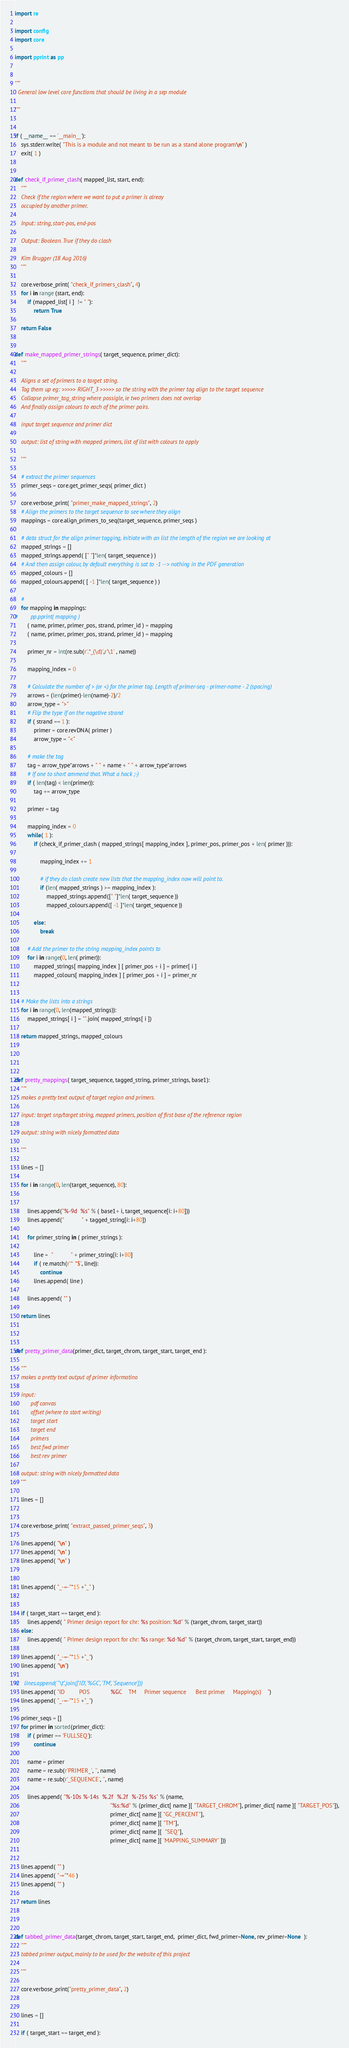<code> <loc_0><loc_0><loc_500><loc_500><_Python_>

import re

import config
import core

import pprint as pp


"""
  General low level core functions that should be living in a sep module

"""


if ( __name__ == '__main__'):
    sys.stderr.write( "This is a module and not meant to be run as a stand alone program\n" )
    exit( 1 )


def check_if_primer_clash( mapped_list, start, end):
    """
    Check if the region where we want to put a primer is alreay 
    occupied by another primer.

    Input: string, start-pos, end-pos
    
    Output: Boolean. True if they do clash
    
    Kim Brugger (18 Aug 2016)
    """
    
    core.verbose_print( "check_if_primers_clash", 4)
    for i in range (start, end):
        if (mapped_list[ i ]  != " "):
            return True 

    return False


def make_mapped_primer_strings( target_sequence, primer_dict):
    """

    Aligns a set of primers to a target string. 
    Tag them up eg: >>>>> RIGHT_3 >>>>> so the string with the primer tag align to the target sequence
    Collapse primer_tag_string where possigle, ie two primers does not overlap
    And finally assign colours to each of the primer pairs.
    
    input target sequence and primer dict
    
    output: list of string with mapped primers, list of list with colours to apply
    
    """

    # extract the primer sequences
    primer_seqs = core.get_primer_seqs( primer_dict )
    
    core.verbose_print( "primer_make_mapped_strings", 2)
    # Align the primers to the target sequence to see where they align
    mappings = core.align_primers_to_seq(target_sequence, primer_seqs )
    
    # data struct for the align primer tagging, initiate with an list the length of the region we are looking at
    mapped_strings = []
    mapped_strings.append( [" "]*len( target_sequence ) )
    # And then assign colour, by default everything is sat to -1 --> nothing in the PDF generation
    mapped_colours = []
    mapped_colours.append( [ -1 ]*len( target_sequence ) )

    #
    for mapping in mappings:
#        pp.pprint( mapping )
        ( name, primer, primer_pos, strand, primer_id ) = mapping
        ( name, primer, primer_pos, strand, primer_id ) = mapping

        primer_nr = int(re.sub(r'.*_(\d)',r'\1' , name))

        mapping_index = 0

        # Calculate the number of > (or <) for the primer tag. Length of primer-seq - primer-name - 2 (spacing)
        arrows = (len(primer)-len(name)-2)/2
        arrow_type = ">"
        # Flip the type if on the nagative strand
        if ( strand == 1 ):
            primer = core.revDNA( primer )
            arrow_type = "<"

        # make the tag
        tag = arrow_type*arrows + " " + name + " " + arrow_type*arrows
        # If one to short ammend that. What a hack ;-)
        if ( len(tag) < len(primer)):
            tag += arrow_type
            
        primer = tag 

        mapping_index = 0
        while( 1 ):
            if (check_if_primer_clash ( mapped_strings[ mapping_index ], primer_pos, primer_pos + len( primer ))):

                mapping_index += 1
                
                # if they do clash create new lists that the mapping_index now will point to.
                if (len( mapped_strings ) >= mapping_index ):
                    mapped_strings.append([" "]*len( target_sequence ))
                    mapped_colours.append([ -1 ]*len( target_sequence ))

            else:
                break

        # Add the primer to the string mapping_index points to
        for i in range(0, len( primer)):
            mapped_strings[ mapping_index ] [ primer_pos + i ] = primer[ i ]
            mapped_colours[ mapping_index ] [ primer_pos + i ] = primer_nr


    # Make the lists into a strings
    for i in range(0, len(mapped_strings)):
        mapped_strings[ i ] = "".join( mapped_strings[ i ])

    return mapped_strings, mapped_colours




def pretty_mappings( target_sequence, tagged_string, primer_strings, base1):
    """
    makes a pretty text output of target region and primers.
    
    input: target snp/target string, mapped primers, position of first base of the reference region
    
    output: string with nicely formatted data
    
    """

    lines = []
    
    for i in range(0, len(target_sequence), 80):


        lines.append("%-9d  %s" % ( base1+ i, target_sequence[i: i+80]))
        lines.append("           " + tagged_string[i: i+80])

        for primer_string in ( primer_strings ):

            line =  "           " + primer_string[i: i+80]
            if ( re.match(r'^ *$', line)):
                continue
            lines.append( line )

        lines.append( "" )

    return lines



def pretty_primer_data(primer_dict, target_chrom, target_start, target_end ):

    """
    makes a pretty text output of primer informatino

    input: 
          pdf canvas
          offset (where to start writing) 
          target start
          target end
          primers
          best fwd primer
          best rev primer

    output: string with nicely formatted data
    """

    lines = []


    core.verbose_print( "extract_passed_primer_seqs", 3)

    lines.append( "\n" )
    lines.append( "\n" )
    lines.append( "\n" )


    lines.append( "_-=-"*15 +"_" )


    if ( target_start == target_end ):
        lines.append( " Primer design report for chr: %s position: %d" % (target_chrom, target_start))
    else:
        lines.append( " Primer design report for chr: %s range: %d-%d" % (target_chrom, target_start, target_end))

    lines.append( "_-=-"*15 +"_")
    lines.append( "\n")

#    lines.append( "\t".join(['ID', '%GC', 'TM', 'Sequence']))
    lines.append( "ID         POS             %GC    TM     Primer sequence      Best primer     Mapping(s)    ")
    lines.append( "_-=-"*15 +"_")

    primer_seqs = []
    for primer in sorted(primer_dict):
        if ( primer == 'FULLSEQ'):
            continue

        name = primer
        name = re.sub(r'PRIMER_', '', name)
        name = re.sub(r'_SEQUENCE', '', name)

        lines.append( "%-10s %-14s  %.2f  %.2f  %-25s %s" % (name,
                                                            "%s:%d" % (primer_dict[ name ][ "TARGET_CHROM"], primer_dict[ name ][ "TARGET_POS"]),
                                                            primer_dict[ name ][ "GC_PERCENT"], 
                                                            primer_dict[ name ][ "TM"],
                                                            primer_dict[ name ][  "SEQ"], 
                                                            primer_dict[ name ][ 'MAPPING_SUMMARY' ]))


    lines.append( "" )
    lines.append( "-="*46 )
    lines.append( "" )

    return lines



def tabbed_primer_data(target_chrom, target_start, target_end,  primer_dict, fwd_primer=None, rev_primer=None  ):
    """
    tabbed primer output, mainly to be used for the website of this project

    """

    core.verbose_print("pretty_primer_data", 2)


    lines = []

    if ( target_start == target_end ):</code> 